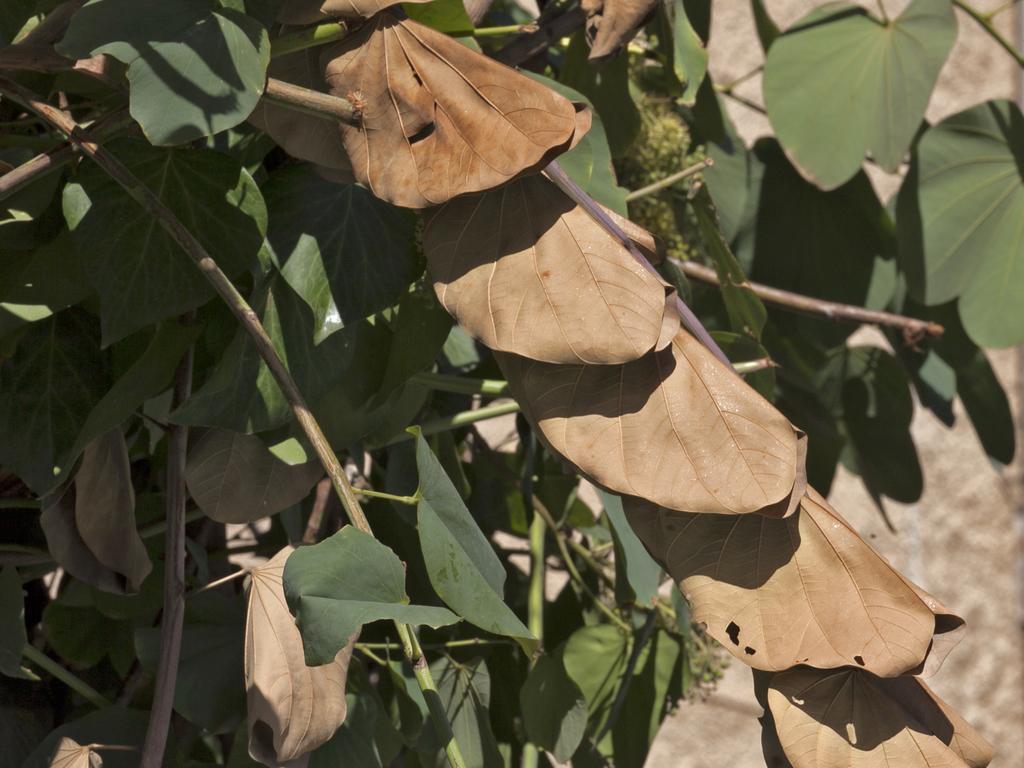Could you give a brief overview of what you see in this image? In this image, we can see a plant with green and brown leaves. 